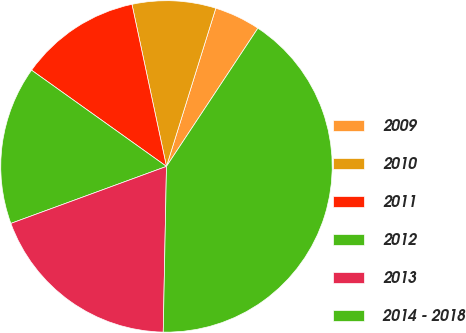Convert chart. <chart><loc_0><loc_0><loc_500><loc_500><pie_chart><fcel>2009<fcel>2010<fcel>2011<fcel>2012<fcel>2013<fcel>2014 - 2018<nl><fcel>4.49%<fcel>8.15%<fcel>11.8%<fcel>15.45%<fcel>19.1%<fcel>41.01%<nl></chart> 